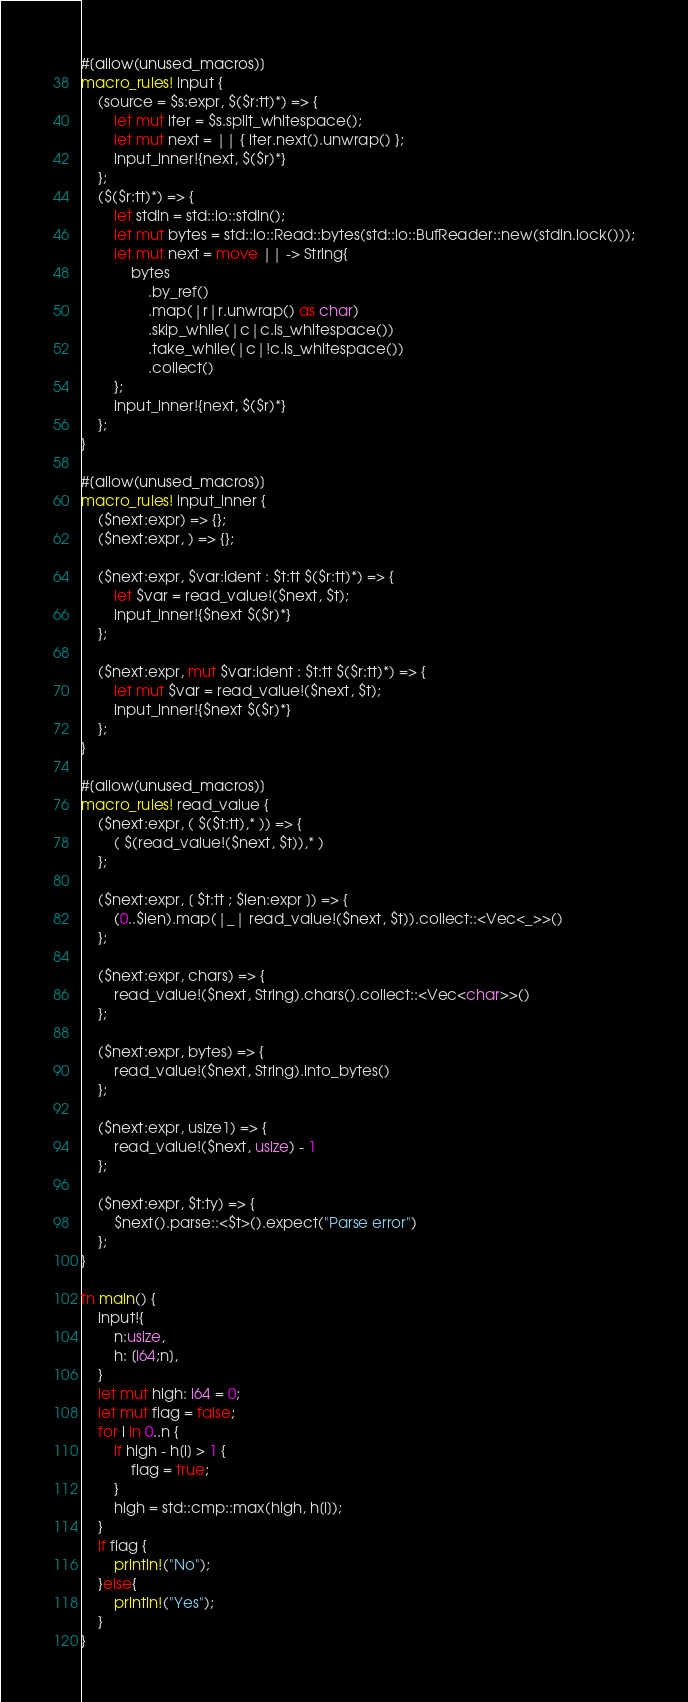<code> <loc_0><loc_0><loc_500><loc_500><_Rust_>#[allow(unused_macros)]
macro_rules! input {
    (source = $s:expr, $($r:tt)*) => {
        let mut iter = $s.split_whitespace();
        let mut next = || { iter.next().unwrap() };
        input_inner!{next, $($r)*}
    };
    ($($r:tt)*) => {
        let stdin = std::io::stdin();
        let mut bytes = std::io::Read::bytes(std::io::BufReader::new(stdin.lock()));
        let mut next = move || -> String{
            bytes
                .by_ref()
                .map(|r|r.unwrap() as char)
                .skip_while(|c|c.is_whitespace())
                .take_while(|c|!c.is_whitespace())
                .collect()
        };
        input_inner!{next, $($r)*}
    };
}

#[allow(unused_macros)]
macro_rules! input_inner {
    ($next:expr) => {};
    ($next:expr, ) => {};

    ($next:expr, $var:ident : $t:tt $($r:tt)*) => {
        let $var = read_value!($next, $t);
        input_inner!{$next $($r)*}
    };

    ($next:expr, mut $var:ident : $t:tt $($r:tt)*) => {
        let mut $var = read_value!($next, $t);
        input_inner!{$next $($r)*}
    };
}

#[allow(unused_macros)]
macro_rules! read_value {
    ($next:expr, ( $($t:tt),* )) => {
        ( $(read_value!($next, $t)),* )
    };

    ($next:expr, [ $t:tt ; $len:expr ]) => {
        (0..$len).map(|_| read_value!($next, $t)).collect::<Vec<_>>()
    };

    ($next:expr, chars) => {
        read_value!($next, String).chars().collect::<Vec<char>>()
    };

    ($next:expr, bytes) => {
        read_value!($next, String).into_bytes()
    };

    ($next:expr, usize1) => {
        read_value!($next, usize) - 1
    };

    ($next:expr, $t:ty) => {
        $next().parse::<$t>().expect("Parse error")
    };
}

fn main() {
    input!{
        n:usize,
        h: [i64;n],
    }
    let mut high: i64 = 0;
    let mut flag = false;
    for i in 0..n {
        if high - h[i] > 1 {
            flag = true;
        }
        high = std::cmp::max(high, h[i]);
    }
    if flag {
        println!("No");
    }else{
        println!("Yes");
    }
}</code> 